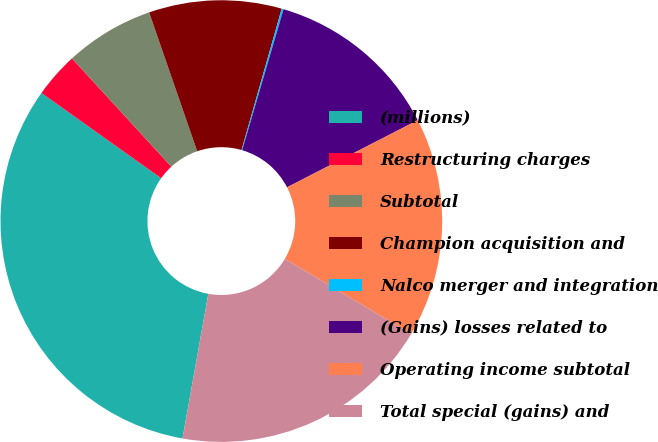<chart> <loc_0><loc_0><loc_500><loc_500><pie_chart><fcel>(millions)<fcel>Restructuring charges<fcel>Subtotal<fcel>Champion acquisition and<fcel>Nalco merger and integration<fcel>(Gains) losses related to<fcel>Operating income subtotal<fcel>Total special (gains) and<nl><fcel>32.04%<fcel>3.33%<fcel>6.52%<fcel>9.71%<fcel>0.14%<fcel>12.9%<fcel>16.09%<fcel>19.28%<nl></chart> 